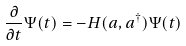<formula> <loc_0><loc_0><loc_500><loc_500>\frac { \partial } { \partial t } \Psi ( t ) = - H ( a , a ^ { \dagger } ) \Psi ( t )</formula> 